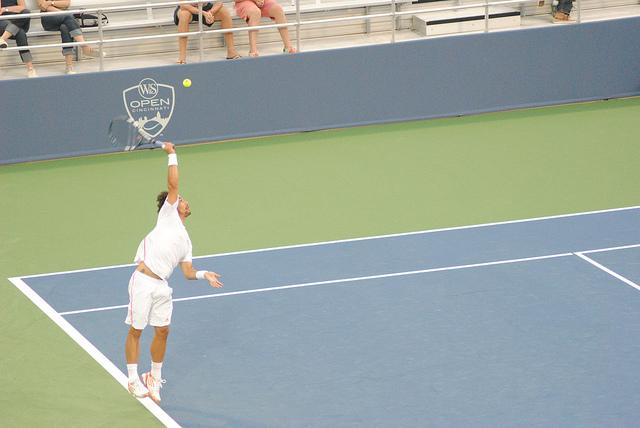What does the W S stand for? western southern 